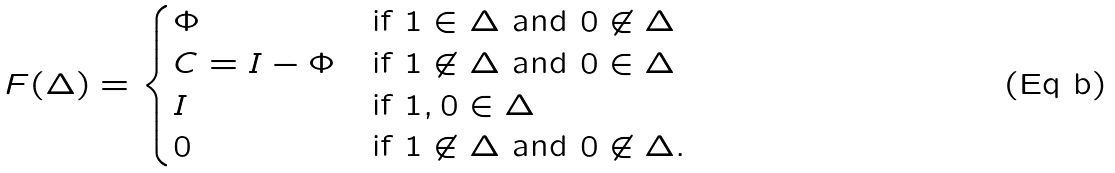<formula> <loc_0><loc_0><loc_500><loc_500>F ( \Delta ) = \begin{cases} \Phi & \text {if $1\in\Delta$ and $0\not\in\Delta$} \\ C = { I } - \Phi & \text {if $1\not\in\Delta$ and $0\in\Delta$} \\ { I } & \text {if ${1,0}\in\Delta$} \\ 0 & \text {if $1\not\in\Delta$ and $0\not\in\Delta$} . \end{cases}</formula> 